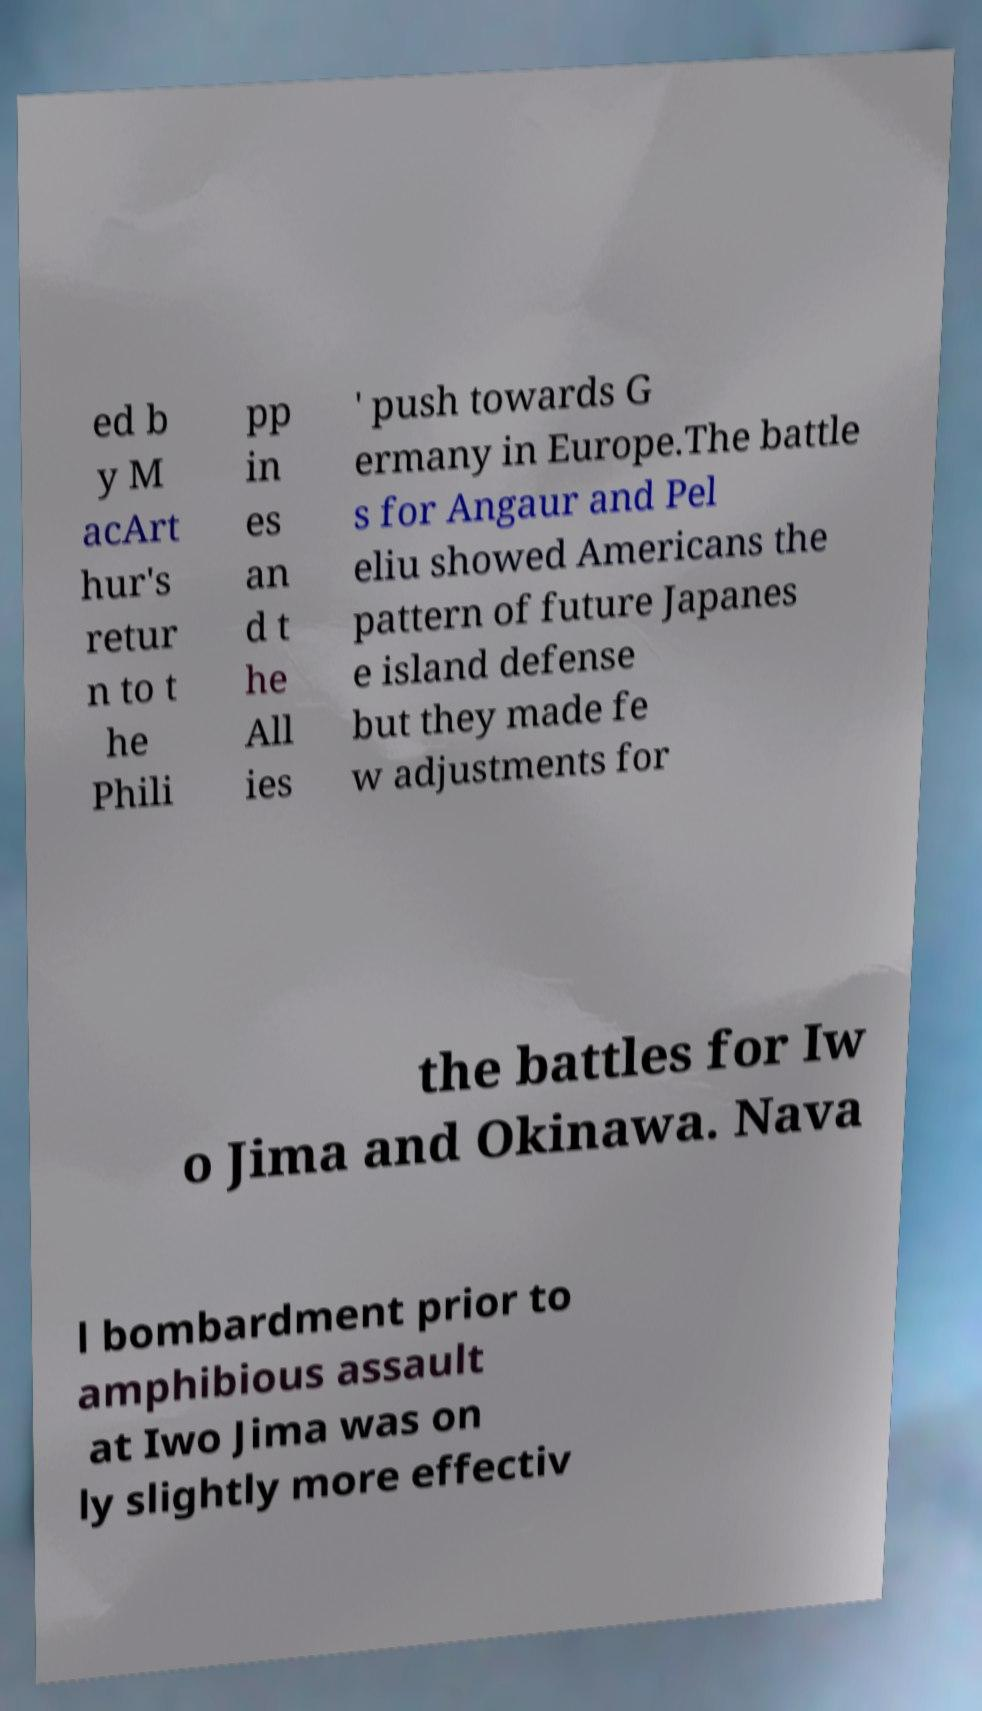I need the written content from this picture converted into text. Can you do that? ed b y M acArt hur's retur n to t he Phili pp in es an d t he All ies ' push towards G ermany in Europe.The battle s for Angaur and Pel eliu showed Americans the pattern of future Japanes e island defense but they made fe w adjustments for the battles for Iw o Jima and Okinawa. Nava l bombardment prior to amphibious assault at Iwo Jima was on ly slightly more effectiv 